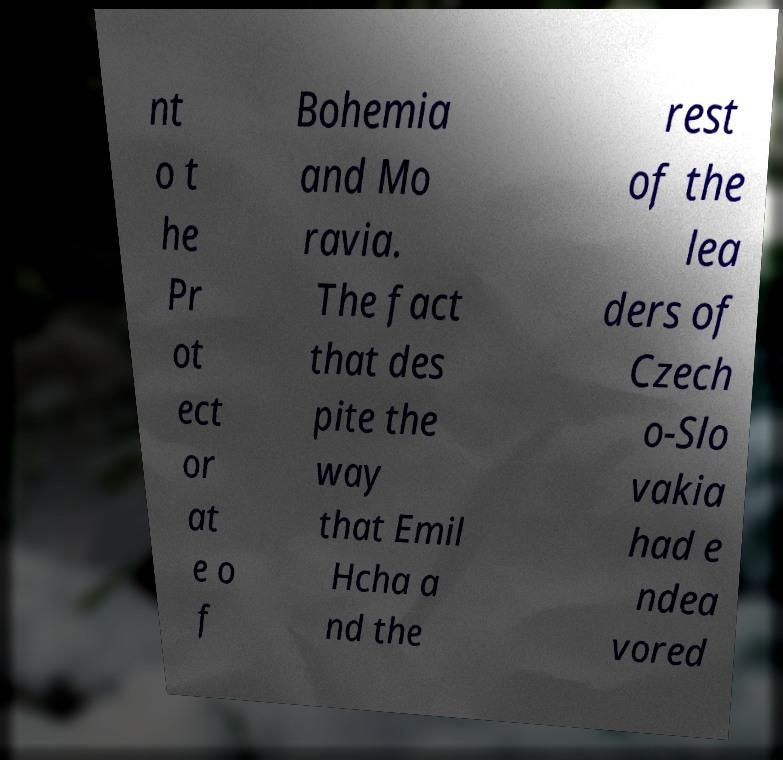I need the written content from this picture converted into text. Can you do that? nt o t he Pr ot ect or at e o f Bohemia and Mo ravia. The fact that des pite the way that Emil Hcha a nd the rest of the lea ders of Czech o-Slo vakia had e ndea vored 